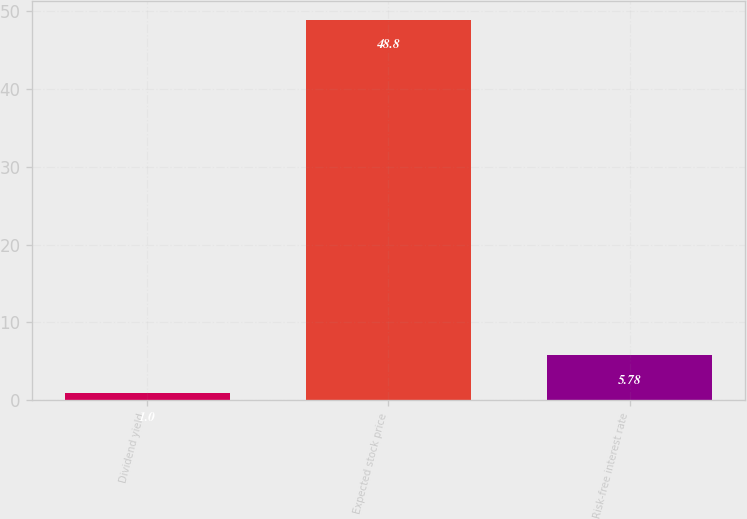Convert chart. <chart><loc_0><loc_0><loc_500><loc_500><bar_chart><fcel>Dividend yield<fcel>Expected stock price<fcel>Risk-free interest rate<nl><fcel>1<fcel>48.8<fcel>5.78<nl></chart> 